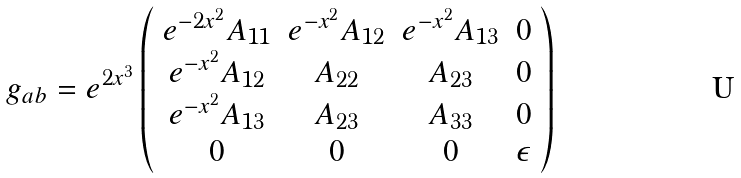<formula> <loc_0><loc_0><loc_500><loc_500>g _ { a b } = e ^ { 2 x ^ { 3 } } \left ( \begin{array} { c c c c } e ^ { - 2 x ^ { 2 } } A _ { 1 1 } & e ^ { - x ^ { 2 } } A _ { 1 2 } & e ^ { - x ^ { 2 } } A _ { 1 3 } & 0 \\ e ^ { - x ^ { 2 } } A _ { 1 2 } & A _ { 2 2 } & A _ { 2 3 } & 0 \\ e ^ { - x ^ { 2 } } A _ { 1 3 } & A _ { 2 3 } & A _ { 3 3 } & 0 \\ 0 & 0 & 0 & \epsilon \end{array} \right )</formula> 